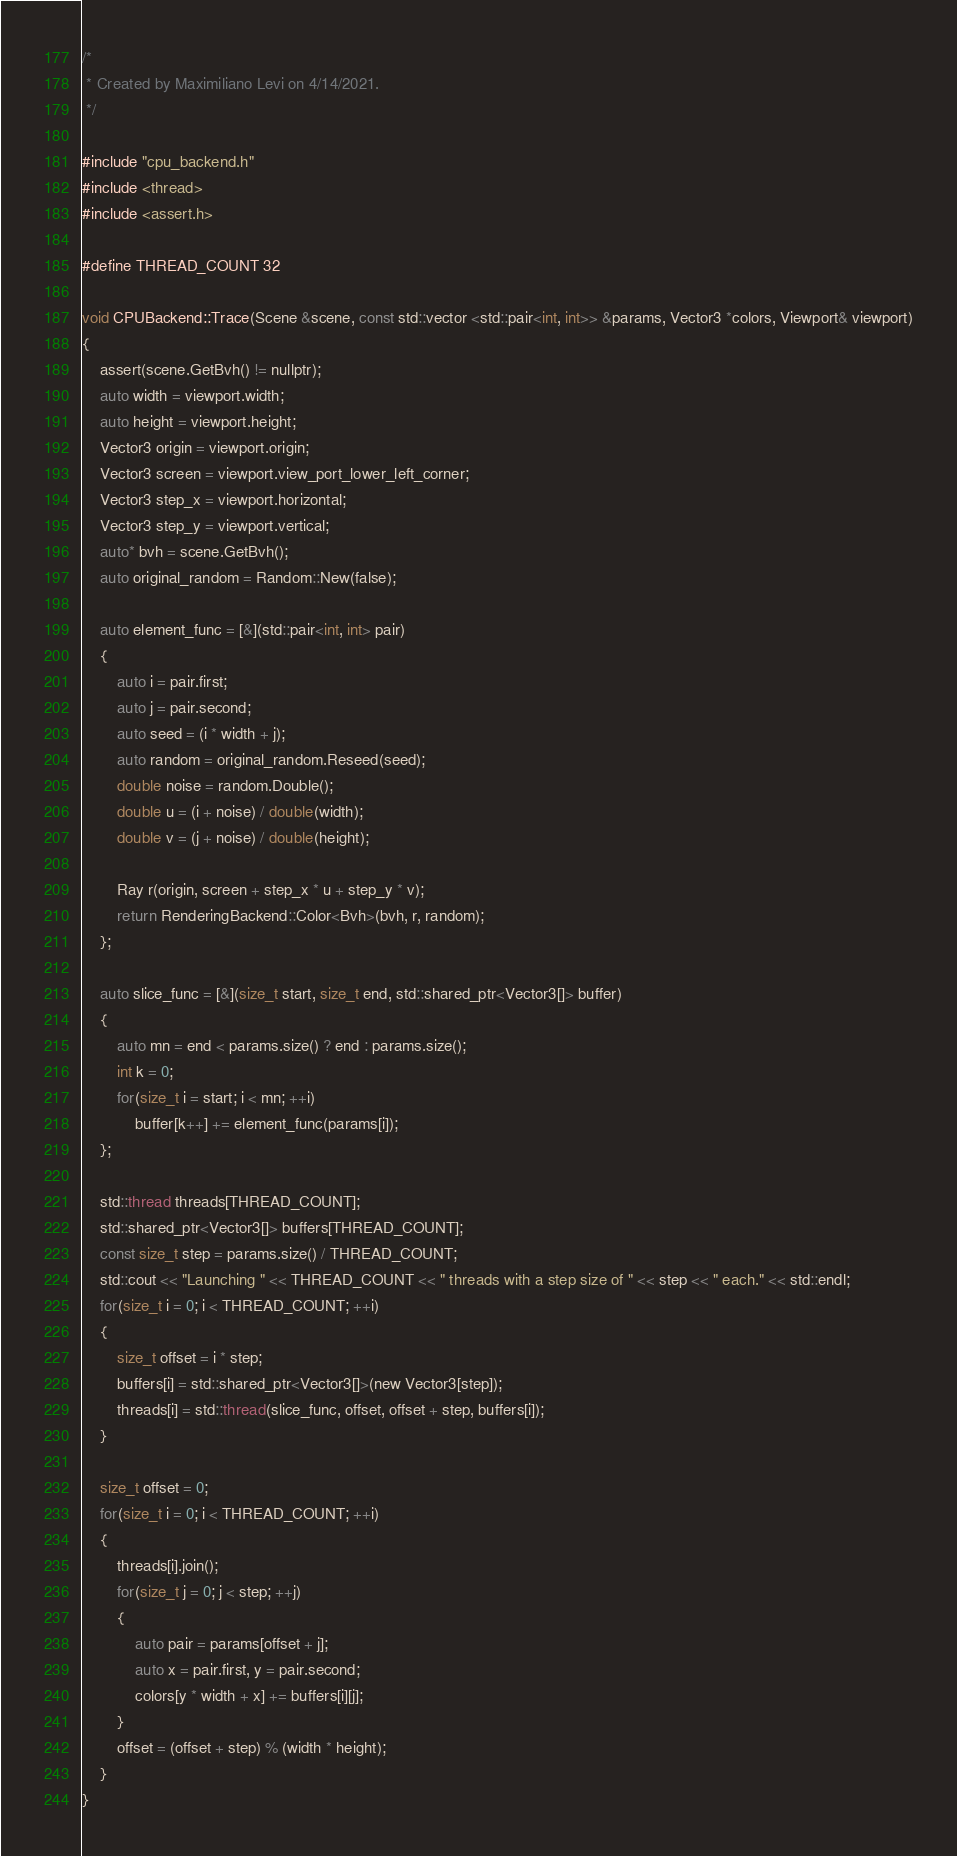Convert code to text. <code><loc_0><loc_0><loc_500><loc_500><_Cuda_>/*
 * Created by Maximiliano Levi on 4/14/2021.
 */

#include "cpu_backend.h"
#include <thread>
#include <assert.h>

#define THREAD_COUNT 32

void CPUBackend::Trace(Scene &scene, const std::vector <std::pair<int, int>> &params, Vector3 *colors, Viewport& viewport)
{
    assert(scene.GetBvh() != nullptr);
    auto width = viewport.width;
    auto height = viewport.height;
    Vector3 origin = viewport.origin;
    Vector3 screen = viewport.view_port_lower_left_corner;
    Vector3 step_x = viewport.horizontal;
    Vector3 step_y = viewport.vertical;
    auto* bvh = scene.GetBvh();
    auto original_random = Random::New(false);

    auto element_func = [&](std::pair<int, int> pair)
    {
        auto i = pair.first;
        auto j = pair.second;
        auto seed = (i * width + j);
        auto random = original_random.Reseed(seed);
        double noise = random.Double();
        double u = (i + noise) / double(width);
        double v = (j + noise) / double(height);

        Ray r(origin, screen + step_x * u + step_y * v);
        return RenderingBackend::Color<Bvh>(bvh, r, random);
    };

    auto slice_func = [&](size_t start, size_t end, std::shared_ptr<Vector3[]> buffer)
    {
        auto mn = end < params.size() ? end : params.size();
        int k = 0;
        for(size_t i = start; i < mn; ++i)
            buffer[k++] += element_func(params[i]);
    };

    std::thread threads[THREAD_COUNT];
    std::shared_ptr<Vector3[]> buffers[THREAD_COUNT];
    const size_t step = params.size() / THREAD_COUNT;
    std::cout << "Launching " << THREAD_COUNT << " threads with a step size of " << step << " each." << std::endl;
    for(size_t i = 0; i < THREAD_COUNT; ++i)
    {
        size_t offset = i * step;
        buffers[i] = std::shared_ptr<Vector3[]>(new Vector3[step]);
        threads[i] = std::thread(slice_func, offset, offset + step, buffers[i]);
    }

    size_t offset = 0;
    for(size_t i = 0; i < THREAD_COUNT; ++i)
    {
        threads[i].join();
        for(size_t j = 0; j < step; ++j)
        {
            auto pair = params[offset + j];
            auto x = pair.first, y = pair.second;
            colors[y * width + x] += buffers[i][j];
        }
        offset = (offset + step) % (width * height);
    }
}</code> 